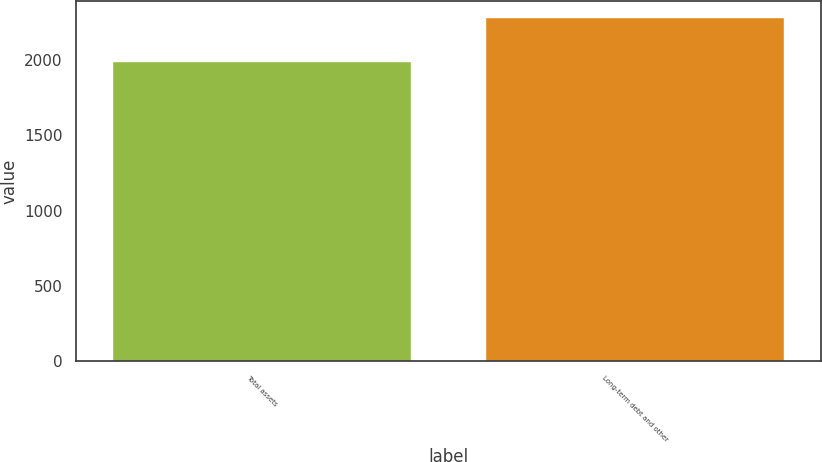Convert chart. <chart><loc_0><loc_0><loc_500><loc_500><bar_chart><fcel>Total assets<fcel>Long-term debt and other<nl><fcel>1990<fcel>2277<nl></chart> 